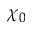Convert formula to latex. <formula><loc_0><loc_0><loc_500><loc_500>\chi _ { 0 }</formula> 